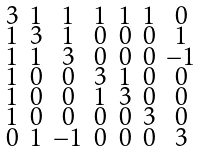<formula> <loc_0><loc_0><loc_500><loc_500>\begin{smallmatrix} 3 & 1 & 1 & 1 & 1 & 1 & 0 \\ 1 & 3 & 1 & 0 & 0 & 0 & 1 \\ 1 & 1 & 3 & 0 & 0 & 0 & - 1 \\ 1 & 0 & 0 & 3 & 1 & 0 & 0 \\ 1 & 0 & 0 & 1 & 3 & 0 & 0 \\ 1 & 0 & 0 & 0 & 0 & 3 & 0 \\ 0 & 1 & - 1 & 0 & 0 & 0 & 3 \end{smallmatrix}</formula> 